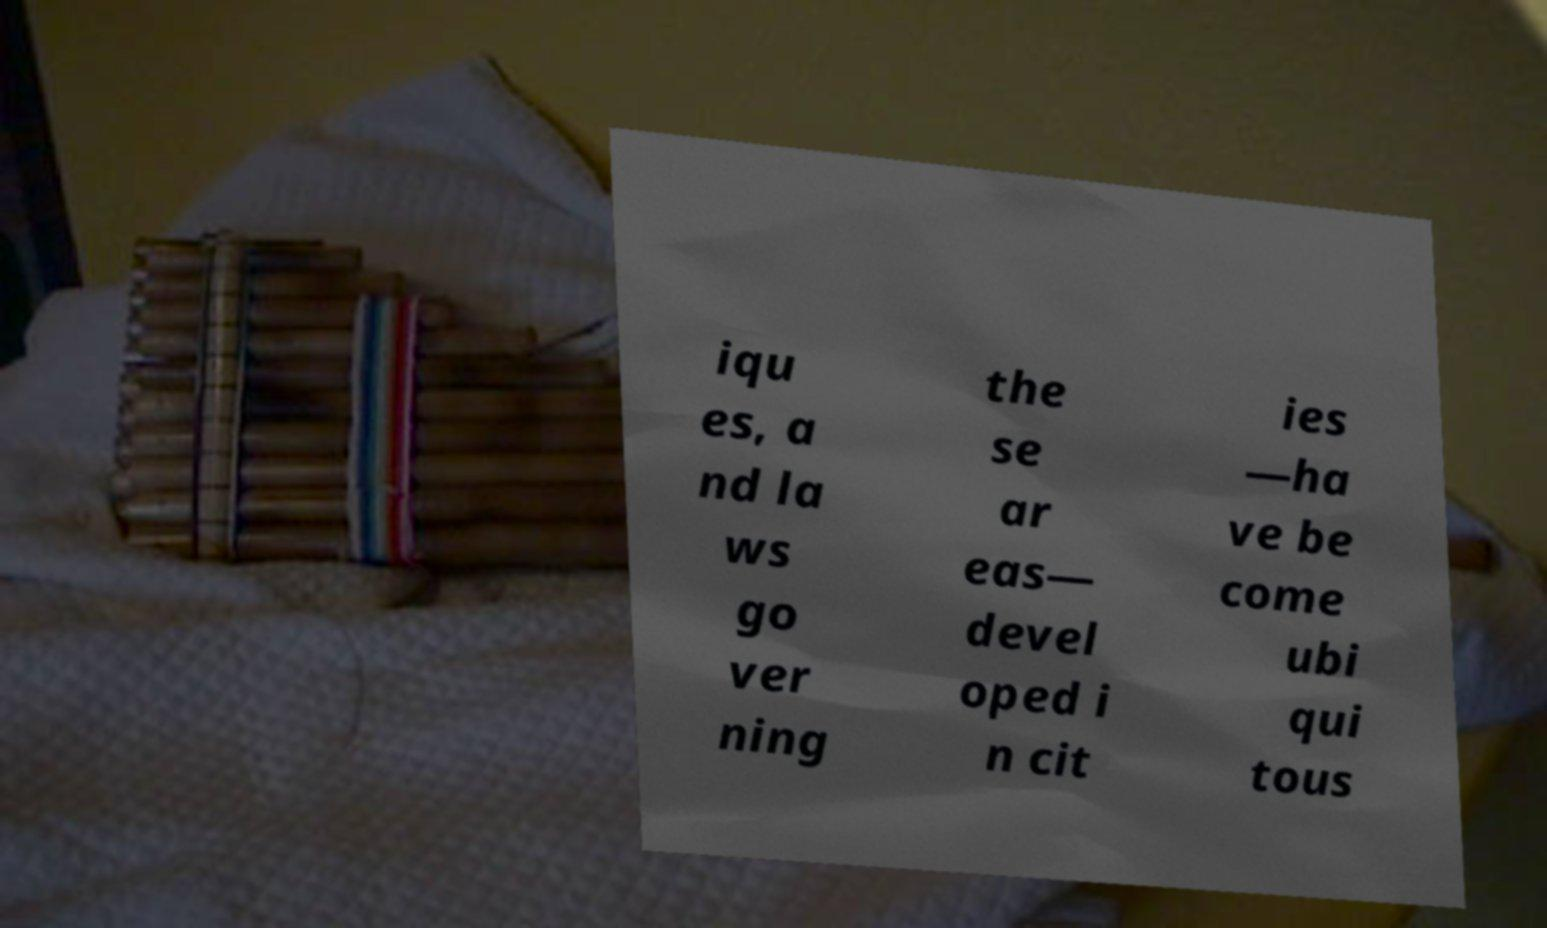Could you assist in decoding the text presented in this image and type it out clearly? iqu es, a nd la ws go ver ning the se ar eas— devel oped i n cit ies —ha ve be come ubi qui tous 